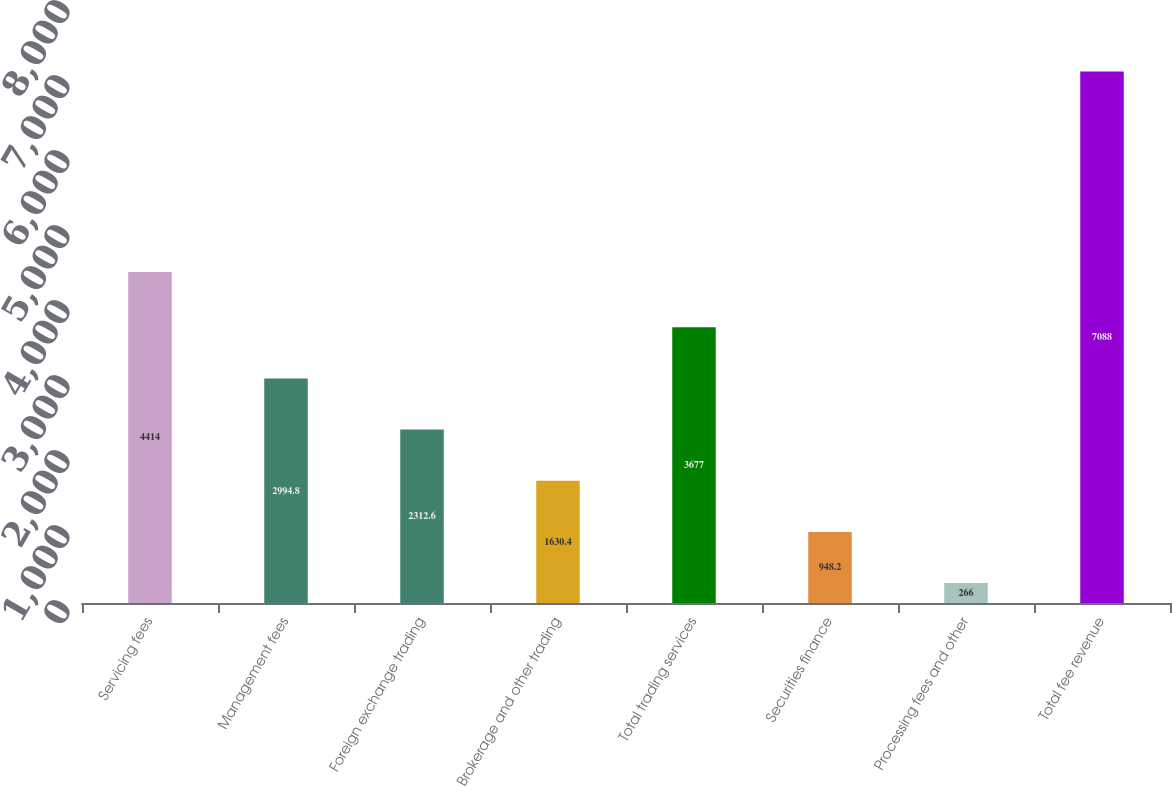Convert chart to OTSL. <chart><loc_0><loc_0><loc_500><loc_500><bar_chart><fcel>Servicing fees<fcel>Management fees<fcel>Foreign exchange trading<fcel>Brokerage and other trading<fcel>Total trading services<fcel>Securities finance<fcel>Processing fees and other<fcel>Total fee revenue<nl><fcel>4414<fcel>2994.8<fcel>2312.6<fcel>1630.4<fcel>3677<fcel>948.2<fcel>266<fcel>7088<nl></chart> 